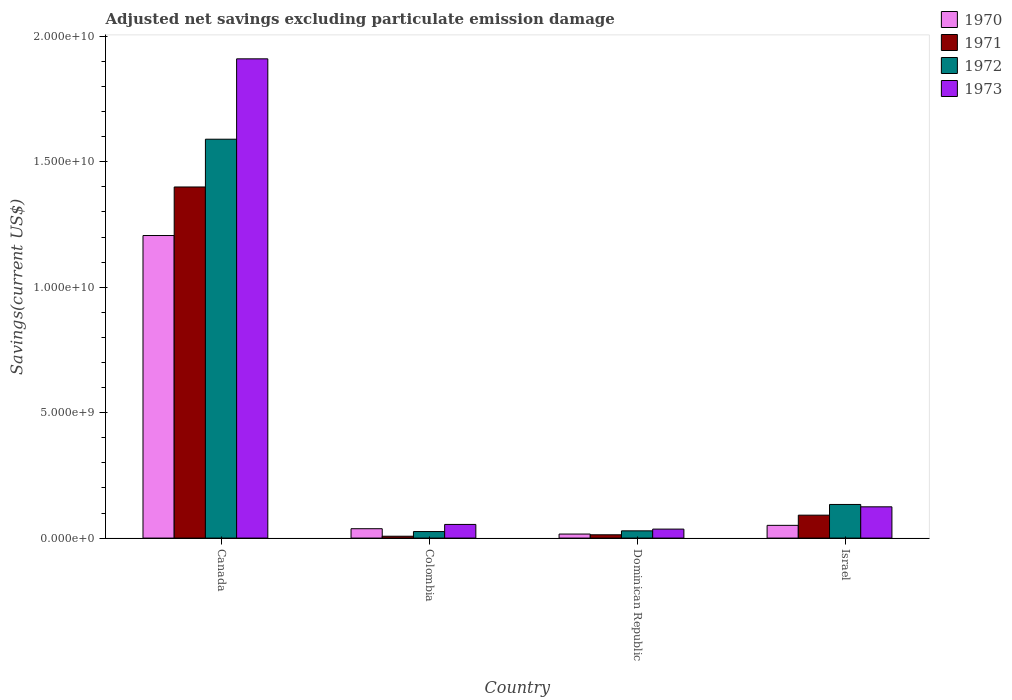How many different coloured bars are there?
Make the answer very short. 4. How many groups of bars are there?
Your answer should be compact. 4. How many bars are there on the 1st tick from the left?
Your response must be concise. 4. How many bars are there on the 2nd tick from the right?
Offer a very short reply. 4. In how many cases, is the number of bars for a given country not equal to the number of legend labels?
Make the answer very short. 0. What is the adjusted net savings in 1972 in Canada?
Provide a succinct answer. 1.59e+1. Across all countries, what is the maximum adjusted net savings in 1970?
Keep it short and to the point. 1.21e+1. Across all countries, what is the minimum adjusted net savings in 1973?
Offer a very short reply. 3.58e+08. In which country was the adjusted net savings in 1973 maximum?
Your response must be concise. Canada. In which country was the adjusted net savings in 1972 minimum?
Make the answer very short. Colombia. What is the total adjusted net savings in 1970 in the graph?
Provide a short and direct response. 1.31e+1. What is the difference between the adjusted net savings in 1972 in Canada and that in Israel?
Provide a short and direct response. 1.46e+1. What is the difference between the adjusted net savings in 1971 in Israel and the adjusted net savings in 1970 in Dominican Republic?
Offer a terse response. 7.53e+08. What is the average adjusted net savings in 1970 per country?
Give a very brief answer. 3.28e+09. What is the difference between the adjusted net savings of/in 1973 and adjusted net savings of/in 1971 in Israel?
Keep it short and to the point. 3.33e+08. What is the ratio of the adjusted net savings in 1972 in Canada to that in Israel?
Offer a terse response. 11.86. Is the adjusted net savings in 1970 in Colombia less than that in Israel?
Give a very brief answer. Yes. Is the difference between the adjusted net savings in 1973 in Colombia and Israel greater than the difference between the adjusted net savings in 1971 in Colombia and Israel?
Your answer should be compact. Yes. What is the difference between the highest and the second highest adjusted net savings in 1970?
Your answer should be very brief. -1.17e+1. What is the difference between the highest and the lowest adjusted net savings in 1972?
Provide a succinct answer. 1.56e+1. In how many countries, is the adjusted net savings in 1971 greater than the average adjusted net savings in 1971 taken over all countries?
Offer a very short reply. 1. Is it the case that in every country, the sum of the adjusted net savings in 1970 and adjusted net savings in 1971 is greater than the sum of adjusted net savings in 1973 and adjusted net savings in 1972?
Offer a terse response. No. What does the 3rd bar from the right in Canada represents?
Give a very brief answer. 1971. Is it the case that in every country, the sum of the adjusted net savings in 1972 and adjusted net savings in 1971 is greater than the adjusted net savings in 1970?
Your answer should be compact. No. Are all the bars in the graph horizontal?
Provide a short and direct response. No. How many countries are there in the graph?
Give a very brief answer. 4. What is the difference between two consecutive major ticks on the Y-axis?
Your answer should be very brief. 5.00e+09. Does the graph contain grids?
Ensure brevity in your answer.  No. How many legend labels are there?
Your answer should be very brief. 4. What is the title of the graph?
Provide a succinct answer. Adjusted net savings excluding particulate emission damage. Does "1984" appear as one of the legend labels in the graph?
Keep it short and to the point. No. What is the label or title of the Y-axis?
Give a very brief answer. Savings(current US$). What is the Savings(current US$) in 1970 in Canada?
Ensure brevity in your answer.  1.21e+1. What is the Savings(current US$) of 1971 in Canada?
Offer a terse response. 1.40e+1. What is the Savings(current US$) in 1972 in Canada?
Offer a terse response. 1.59e+1. What is the Savings(current US$) of 1973 in Canada?
Your answer should be compact. 1.91e+1. What is the Savings(current US$) in 1970 in Colombia?
Your answer should be very brief. 3.74e+08. What is the Savings(current US$) in 1971 in Colombia?
Make the answer very short. 7.46e+07. What is the Savings(current US$) in 1972 in Colombia?
Offer a very short reply. 2.60e+08. What is the Savings(current US$) of 1973 in Colombia?
Provide a succinct answer. 5.45e+08. What is the Savings(current US$) in 1970 in Dominican Republic?
Offer a terse response. 1.61e+08. What is the Savings(current US$) of 1971 in Dominican Republic?
Offer a terse response. 1.32e+08. What is the Savings(current US$) of 1972 in Dominican Republic?
Give a very brief answer. 2.89e+08. What is the Savings(current US$) of 1973 in Dominican Republic?
Offer a terse response. 3.58e+08. What is the Savings(current US$) in 1970 in Israel?
Your answer should be compact. 5.08e+08. What is the Savings(current US$) in 1971 in Israel?
Offer a terse response. 9.14e+08. What is the Savings(current US$) in 1972 in Israel?
Offer a terse response. 1.34e+09. What is the Savings(current US$) of 1973 in Israel?
Offer a terse response. 1.25e+09. Across all countries, what is the maximum Savings(current US$) of 1970?
Provide a succinct answer. 1.21e+1. Across all countries, what is the maximum Savings(current US$) in 1971?
Your answer should be compact. 1.40e+1. Across all countries, what is the maximum Savings(current US$) of 1972?
Offer a terse response. 1.59e+1. Across all countries, what is the maximum Savings(current US$) in 1973?
Keep it short and to the point. 1.91e+1. Across all countries, what is the minimum Savings(current US$) in 1970?
Offer a very short reply. 1.61e+08. Across all countries, what is the minimum Savings(current US$) in 1971?
Keep it short and to the point. 7.46e+07. Across all countries, what is the minimum Savings(current US$) in 1972?
Provide a short and direct response. 2.60e+08. Across all countries, what is the minimum Savings(current US$) of 1973?
Your answer should be very brief. 3.58e+08. What is the total Savings(current US$) of 1970 in the graph?
Offer a very short reply. 1.31e+1. What is the total Savings(current US$) of 1971 in the graph?
Your answer should be compact. 1.51e+1. What is the total Savings(current US$) in 1972 in the graph?
Provide a short and direct response. 1.78e+1. What is the total Savings(current US$) of 1973 in the graph?
Ensure brevity in your answer.  2.13e+1. What is the difference between the Savings(current US$) in 1970 in Canada and that in Colombia?
Ensure brevity in your answer.  1.17e+1. What is the difference between the Savings(current US$) in 1971 in Canada and that in Colombia?
Give a very brief answer. 1.39e+1. What is the difference between the Savings(current US$) in 1972 in Canada and that in Colombia?
Your response must be concise. 1.56e+1. What is the difference between the Savings(current US$) of 1973 in Canada and that in Colombia?
Provide a succinct answer. 1.86e+1. What is the difference between the Savings(current US$) of 1970 in Canada and that in Dominican Republic?
Your response must be concise. 1.19e+1. What is the difference between the Savings(current US$) of 1971 in Canada and that in Dominican Republic?
Provide a succinct answer. 1.39e+1. What is the difference between the Savings(current US$) of 1972 in Canada and that in Dominican Republic?
Offer a terse response. 1.56e+1. What is the difference between the Savings(current US$) of 1973 in Canada and that in Dominican Republic?
Provide a short and direct response. 1.87e+1. What is the difference between the Savings(current US$) of 1970 in Canada and that in Israel?
Give a very brief answer. 1.16e+1. What is the difference between the Savings(current US$) of 1971 in Canada and that in Israel?
Give a very brief answer. 1.31e+1. What is the difference between the Savings(current US$) of 1972 in Canada and that in Israel?
Offer a very short reply. 1.46e+1. What is the difference between the Savings(current US$) of 1973 in Canada and that in Israel?
Offer a terse response. 1.79e+1. What is the difference between the Savings(current US$) of 1970 in Colombia and that in Dominican Republic?
Make the answer very short. 2.13e+08. What is the difference between the Savings(current US$) in 1971 in Colombia and that in Dominican Republic?
Offer a terse response. -5.69e+07. What is the difference between the Savings(current US$) in 1972 in Colombia and that in Dominican Republic?
Provide a short and direct response. -2.84e+07. What is the difference between the Savings(current US$) of 1973 in Colombia and that in Dominican Republic?
Provide a short and direct response. 1.87e+08. What is the difference between the Savings(current US$) of 1970 in Colombia and that in Israel?
Make the answer very short. -1.34e+08. What is the difference between the Savings(current US$) in 1971 in Colombia and that in Israel?
Provide a succinct answer. -8.40e+08. What is the difference between the Savings(current US$) of 1972 in Colombia and that in Israel?
Offer a very short reply. -1.08e+09. What is the difference between the Savings(current US$) of 1973 in Colombia and that in Israel?
Make the answer very short. -7.02e+08. What is the difference between the Savings(current US$) in 1970 in Dominican Republic and that in Israel?
Ensure brevity in your answer.  -3.47e+08. What is the difference between the Savings(current US$) in 1971 in Dominican Republic and that in Israel?
Keep it short and to the point. -7.83e+08. What is the difference between the Savings(current US$) in 1972 in Dominican Republic and that in Israel?
Give a very brief answer. -1.05e+09. What is the difference between the Savings(current US$) in 1973 in Dominican Republic and that in Israel?
Provide a short and direct response. -8.89e+08. What is the difference between the Savings(current US$) in 1970 in Canada and the Savings(current US$) in 1971 in Colombia?
Your answer should be very brief. 1.20e+1. What is the difference between the Savings(current US$) in 1970 in Canada and the Savings(current US$) in 1972 in Colombia?
Keep it short and to the point. 1.18e+1. What is the difference between the Savings(current US$) of 1970 in Canada and the Savings(current US$) of 1973 in Colombia?
Your answer should be compact. 1.15e+1. What is the difference between the Savings(current US$) of 1971 in Canada and the Savings(current US$) of 1972 in Colombia?
Offer a very short reply. 1.37e+1. What is the difference between the Savings(current US$) in 1971 in Canada and the Savings(current US$) in 1973 in Colombia?
Offer a terse response. 1.35e+1. What is the difference between the Savings(current US$) of 1972 in Canada and the Savings(current US$) of 1973 in Colombia?
Provide a short and direct response. 1.54e+1. What is the difference between the Savings(current US$) of 1970 in Canada and the Savings(current US$) of 1971 in Dominican Republic?
Ensure brevity in your answer.  1.19e+1. What is the difference between the Savings(current US$) of 1970 in Canada and the Savings(current US$) of 1972 in Dominican Republic?
Offer a terse response. 1.18e+1. What is the difference between the Savings(current US$) of 1970 in Canada and the Savings(current US$) of 1973 in Dominican Republic?
Give a very brief answer. 1.17e+1. What is the difference between the Savings(current US$) in 1971 in Canada and the Savings(current US$) in 1972 in Dominican Republic?
Provide a short and direct response. 1.37e+1. What is the difference between the Savings(current US$) in 1971 in Canada and the Savings(current US$) in 1973 in Dominican Republic?
Your answer should be compact. 1.36e+1. What is the difference between the Savings(current US$) in 1972 in Canada and the Savings(current US$) in 1973 in Dominican Republic?
Give a very brief answer. 1.55e+1. What is the difference between the Savings(current US$) of 1970 in Canada and the Savings(current US$) of 1971 in Israel?
Give a very brief answer. 1.11e+1. What is the difference between the Savings(current US$) in 1970 in Canada and the Savings(current US$) in 1972 in Israel?
Provide a short and direct response. 1.07e+1. What is the difference between the Savings(current US$) in 1970 in Canada and the Savings(current US$) in 1973 in Israel?
Make the answer very short. 1.08e+1. What is the difference between the Savings(current US$) in 1971 in Canada and the Savings(current US$) in 1972 in Israel?
Your response must be concise. 1.27e+1. What is the difference between the Savings(current US$) of 1971 in Canada and the Savings(current US$) of 1973 in Israel?
Your response must be concise. 1.27e+1. What is the difference between the Savings(current US$) in 1972 in Canada and the Savings(current US$) in 1973 in Israel?
Your response must be concise. 1.47e+1. What is the difference between the Savings(current US$) of 1970 in Colombia and the Savings(current US$) of 1971 in Dominican Republic?
Provide a succinct answer. 2.42e+08. What is the difference between the Savings(current US$) of 1970 in Colombia and the Savings(current US$) of 1972 in Dominican Republic?
Give a very brief answer. 8.52e+07. What is the difference between the Savings(current US$) in 1970 in Colombia and the Savings(current US$) in 1973 in Dominican Republic?
Give a very brief answer. 1.57e+07. What is the difference between the Savings(current US$) in 1971 in Colombia and the Savings(current US$) in 1972 in Dominican Republic?
Ensure brevity in your answer.  -2.14e+08. What is the difference between the Savings(current US$) in 1971 in Colombia and the Savings(current US$) in 1973 in Dominican Republic?
Make the answer very short. -2.84e+08. What is the difference between the Savings(current US$) in 1972 in Colombia and the Savings(current US$) in 1973 in Dominican Republic?
Provide a succinct answer. -9.79e+07. What is the difference between the Savings(current US$) of 1970 in Colombia and the Savings(current US$) of 1971 in Israel?
Your answer should be very brief. -5.40e+08. What is the difference between the Savings(current US$) in 1970 in Colombia and the Savings(current US$) in 1972 in Israel?
Your answer should be very brief. -9.67e+08. What is the difference between the Savings(current US$) in 1970 in Colombia and the Savings(current US$) in 1973 in Israel?
Give a very brief answer. -8.73e+08. What is the difference between the Savings(current US$) in 1971 in Colombia and the Savings(current US$) in 1972 in Israel?
Keep it short and to the point. -1.27e+09. What is the difference between the Savings(current US$) of 1971 in Colombia and the Savings(current US$) of 1973 in Israel?
Offer a very short reply. -1.17e+09. What is the difference between the Savings(current US$) of 1972 in Colombia and the Savings(current US$) of 1973 in Israel?
Provide a succinct answer. -9.87e+08. What is the difference between the Savings(current US$) of 1970 in Dominican Republic and the Savings(current US$) of 1971 in Israel?
Offer a terse response. -7.53e+08. What is the difference between the Savings(current US$) of 1970 in Dominican Republic and the Savings(current US$) of 1972 in Israel?
Your answer should be very brief. -1.18e+09. What is the difference between the Savings(current US$) of 1970 in Dominican Republic and the Savings(current US$) of 1973 in Israel?
Keep it short and to the point. -1.09e+09. What is the difference between the Savings(current US$) of 1971 in Dominican Republic and the Savings(current US$) of 1972 in Israel?
Provide a short and direct response. -1.21e+09. What is the difference between the Savings(current US$) in 1971 in Dominican Republic and the Savings(current US$) in 1973 in Israel?
Your answer should be compact. -1.12e+09. What is the difference between the Savings(current US$) of 1972 in Dominican Republic and the Savings(current US$) of 1973 in Israel?
Offer a terse response. -9.58e+08. What is the average Savings(current US$) in 1970 per country?
Your response must be concise. 3.28e+09. What is the average Savings(current US$) of 1971 per country?
Ensure brevity in your answer.  3.78e+09. What is the average Savings(current US$) in 1972 per country?
Your answer should be compact. 4.45e+09. What is the average Savings(current US$) of 1973 per country?
Your answer should be compact. 5.31e+09. What is the difference between the Savings(current US$) of 1970 and Savings(current US$) of 1971 in Canada?
Your answer should be very brief. -1.94e+09. What is the difference between the Savings(current US$) of 1970 and Savings(current US$) of 1972 in Canada?
Your answer should be very brief. -3.84e+09. What is the difference between the Savings(current US$) in 1970 and Savings(current US$) in 1973 in Canada?
Your answer should be compact. -7.04e+09. What is the difference between the Savings(current US$) of 1971 and Savings(current US$) of 1972 in Canada?
Ensure brevity in your answer.  -1.90e+09. What is the difference between the Savings(current US$) in 1971 and Savings(current US$) in 1973 in Canada?
Keep it short and to the point. -5.11e+09. What is the difference between the Savings(current US$) in 1972 and Savings(current US$) in 1973 in Canada?
Offer a terse response. -3.20e+09. What is the difference between the Savings(current US$) in 1970 and Savings(current US$) in 1971 in Colombia?
Provide a short and direct response. 2.99e+08. What is the difference between the Savings(current US$) of 1970 and Savings(current US$) of 1972 in Colombia?
Make the answer very short. 1.14e+08. What is the difference between the Savings(current US$) in 1970 and Savings(current US$) in 1973 in Colombia?
Your answer should be compact. -1.71e+08. What is the difference between the Savings(current US$) in 1971 and Savings(current US$) in 1972 in Colombia?
Your response must be concise. -1.86e+08. What is the difference between the Savings(current US$) of 1971 and Savings(current US$) of 1973 in Colombia?
Provide a short and direct response. -4.70e+08. What is the difference between the Savings(current US$) in 1972 and Savings(current US$) in 1973 in Colombia?
Keep it short and to the point. -2.85e+08. What is the difference between the Savings(current US$) of 1970 and Savings(current US$) of 1971 in Dominican Republic?
Provide a short and direct response. 2.96e+07. What is the difference between the Savings(current US$) in 1970 and Savings(current US$) in 1972 in Dominican Republic?
Make the answer very short. -1.28e+08. What is the difference between the Savings(current US$) in 1970 and Savings(current US$) in 1973 in Dominican Republic?
Your answer should be compact. -1.97e+08. What is the difference between the Savings(current US$) of 1971 and Savings(current US$) of 1972 in Dominican Republic?
Ensure brevity in your answer.  -1.57e+08. What is the difference between the Savings(current US$) of 1971 and Savings(current US$) of 1973 in Dominican Republic?
Offer a very short reply. -2.27e+08. What is the difference between the Savings(current US$) of 1972 and Savings(current US$) of 1973 in Dominican Republic?
Keep it short and to the point. -6.95e+07. What is the difference between the Savings(current US$) of 1970 and Savings(current US$) of 1971 in Israel?
Your response must be concise. -4.06e+08. What is the difference between the Savings(current US$) in 1970 and Savings(current US$) in 1972 in Israel?
Give a very brief answer. -8.33e+08. What is the difference between the Savings(current US$) of 1970 and Savings(current US$) of 1973 in Israel?
Offer a terse response. -7.39e+08. What is the difference between the Savings(current US$) in 1971 and Savings(current US$) in 1972 in Israel?
Provide a short and direct response. -4.27e+08. What is the difference between the Savings(current US$) of 1971 and Savings(current US$) of 1973 in Israel?
Keep it short and to the point. -3.33e+08. What is the difference between the Savings(current US$) in 1972 and Savings(current US$) in 1973 in Israel?
Your response must be concise. 9.40e+07. What is the ratio of the Savings(current US$) of 1970 in Canada to that in Colombia?
Give a very brief answer. 32.26. What is the ratio of the Savings(current US$) of 1971 in Canada to that in Colombia?
Make the answer very short. 187.59. What is the ratio of the Savings(current US$) in 1972 in Canada to that in Colombia?
Ensure brevity in your answer.  61.09. What is the ratio of the Savings(current US$) of 1973 in Canada to that in Colombia?
Offer a terse response. 35.07. What is the ratio of the Savings(current US$) in 1970 in Canada to that in Dominican Republic?
Your response must be concise. 74.87. What is the ratio of the Savings(current US$) of 1971 in Canada to that in Dominican Republic?
Your answer should be very brief. 106.4. What is the ratio of the Savings(current US$) of 1972 in Canada to that in Dominican Republic?
Your answer should be very brief. 55.08. What is the ratio of the Savings(current US$) of 1973 in Canada to that in Dominican Republic?
Ensure brevity in your answer.  53.33. What is the ratio of the Savings(current US$) in 1970 in Canada to that in Israel?
Ensure brevity in your answer.  23.75. What is the ratio of the Savings(current US$) in 1971 in Canada to that in Israel?
Keep it short and to the point. 15.31. What is the ratio of the Savings(current US$) in 1972 in Canada to that in Israel?
Provide a succinct answer. 11.86. What is the ratio of the Savings(current US$) in 1973 in Canada to that in Israel?
Offer a very short reply. 15.32. What is the ratio of the Savings(current US$) of 1970 in Colombia to that in Dominican Republic?
Make the answer very short. 2.32. What is the ratio of the Savings(current US$) of 1971 in Colombia to that in Dominican Republic?
Your answer should be compact. 0.57. What is the ratio of the Savings(current US$) in 1972 in Colombia to that in Dominican Republic?
Keep it short and to the point. 0.9. What is the ratio of the Savings(current US$) of 1973 in Colombia to that in Dominican Republic?
Ensure brevity in your answer.  1.52. What is the ratio of the Savings(current US$) of 1970 in Colombia to that in Israel?
Ensure brevity in your answer.  0.74. What is the ratio of the Savings(current US$) of 1971 in Colombia to that in Israel?
Make the answer very short. 0.08. What is the ratio of the Savings(current US$) in 1972 in Colombia to that in Israel?
Ensure brevity in your answer.  0.19. What is the ratio of the Savings(current US$) in 1973 in Colombia to that in Israel?
Offer a very short reply. 0.44. What is the ratio of the Savings(current US$) of 1970 in Dominican Republic to that in Israel?
Your answer should be very brief. 0.32. What is the ratio of the Savings(current US$) in 1971 in Dominican Republic to that in Israel?
Offer a terse response. 0.14. What is the ratio of the Savings(current US$) in 1972 in Dominican Republic to that in Israel?
Your answer should be compact. 0.22. What is the ratio of the Savings(current US$) in 1973 in Dominican Republic to that in Israel?
Give a very brief answer. 0.29. What is the difference between the highest and the second highest Savings(current US$) in 1970?
Ensure brevity in your answer.  1.16e+1. What is the difference between the highest and the second highest Savings(current US$) in 1971?
Give a very brief answer. 1.31e+1. What is the difference between the highest and the second highest Savings(current US$) of 1972?
Your answer should be compact. 1.46e+1. What is the difference between the highest and the second highest Savings(current US$) in 1973?
Your answer should be very brief. 1.79e+1. What is the difference between the highest and the lowest Savings(current US$) of 1970?
Keep it short and to the point. 1.19e+1. What is the difference between the highest and the lowest Savings(current US$) in 1971?
Offer a very short reply. 1.39e+1. What is the difference between the highest and the lowest Savings(current US$) of 1972?
Offer a terse response. 1.56e+1. What is the difference between the highest and the lowest Savings(current US$) of 1973?
Offer a very short reply. 1.87e+1. 